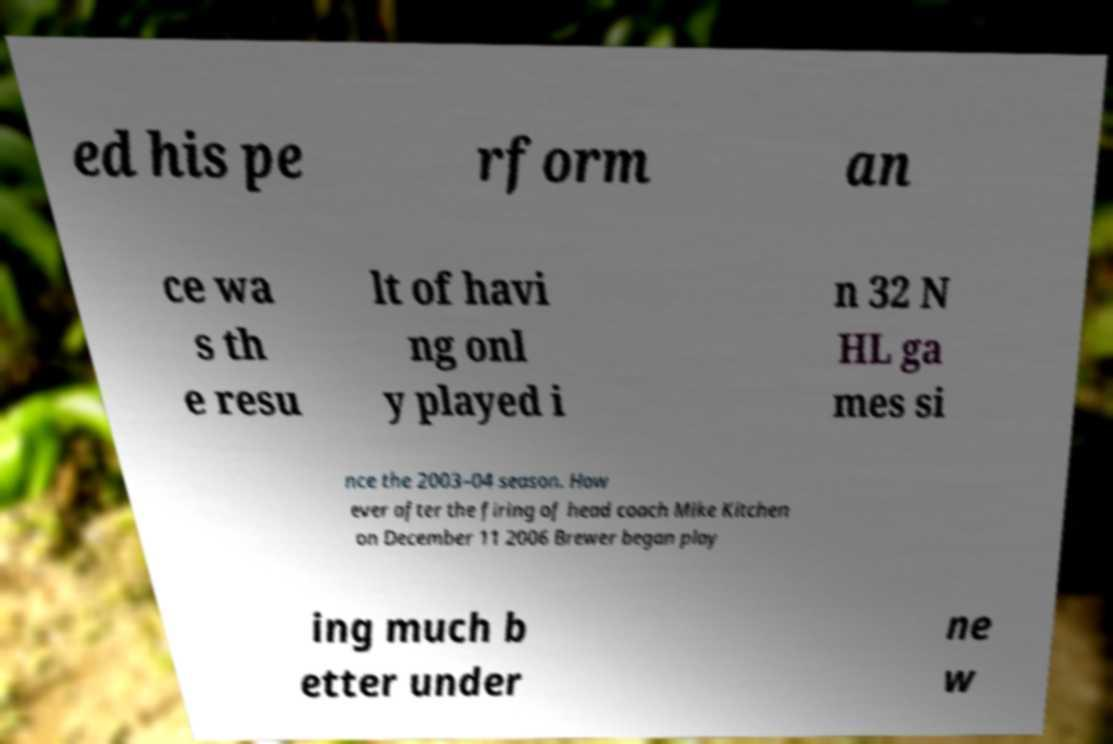Please identify and transcribe the text found in this image. ed his pe rform an ce wa s th e resu lt of havi ng onl y played i n 32 N HL ga mes si nce the 2003–04 season. How ever after the firing of head coach Mike Kitchen on December 11 2006 Brewer began play ing much b etter under ne w 